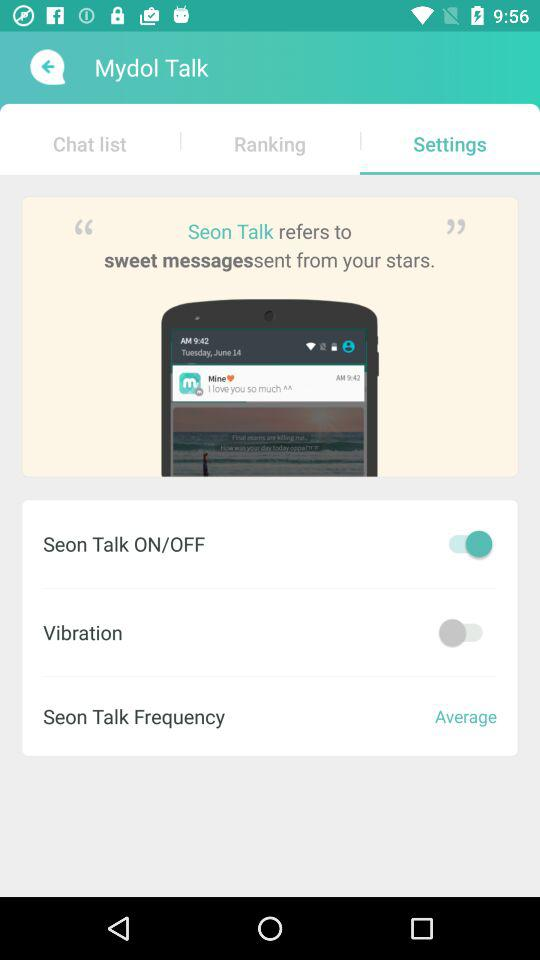What tab is selected? The selected tab is "Settings". 